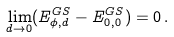<formula> <loc_0><loc_0><loc_500><loc_500>\lim _ { d \to 0 } ( E ^ { G S } _ { \phi , d } - E ^ { G S } _ { 0 , 0 } ) = 0 \, .</formula> 